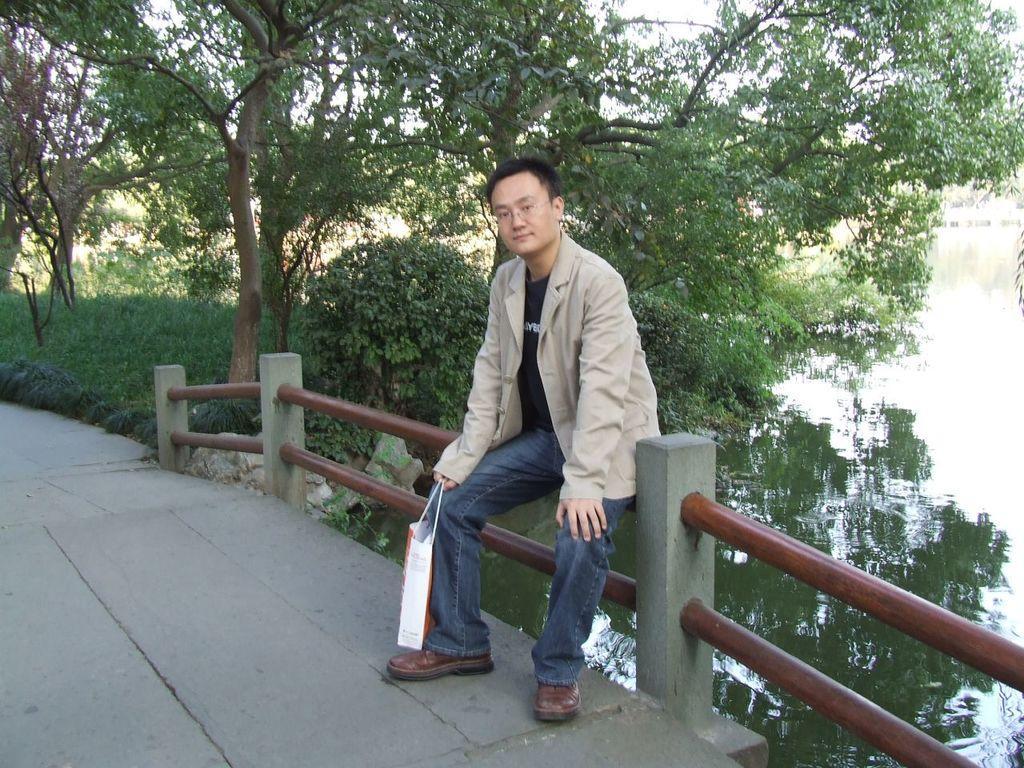Please provide a concise description of this image. At the bottom of the image there is a bridge, on the bridge there is fencing. On the fencing a man is sitting and smiling. Behind him there is water and there are some trees. 